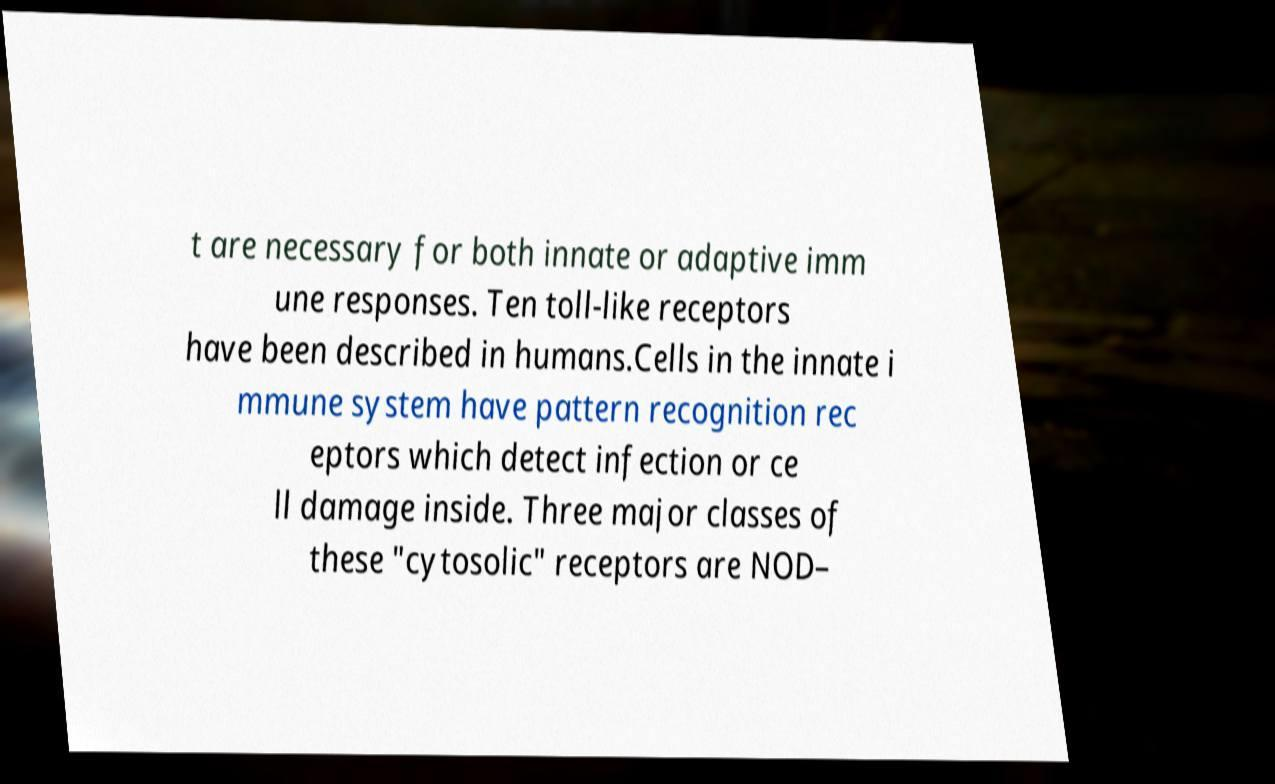Please identify and transcribe the text found in this image. t are necessary for both innate or adaptive imm une responses. Ten toll-like receptors have been described in humans.Cells in the innate i mmune system have pattern recognition rec eptors which detect infection or ce ll damage inside. Three major classes of these "cytosolic" receptors are NOD– 